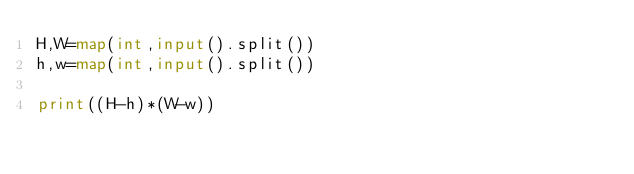Convert code to text. <code><loc_0><loc_0><loc_500><loc_500><_Python_>H,W=map(int,input().split())
h,w=map(int,input().split())

print((H-h)*(W-w))</code> 